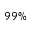<formula> <loc_0><loc_0><loc_500><loc_500>9 9 \%</formula> 